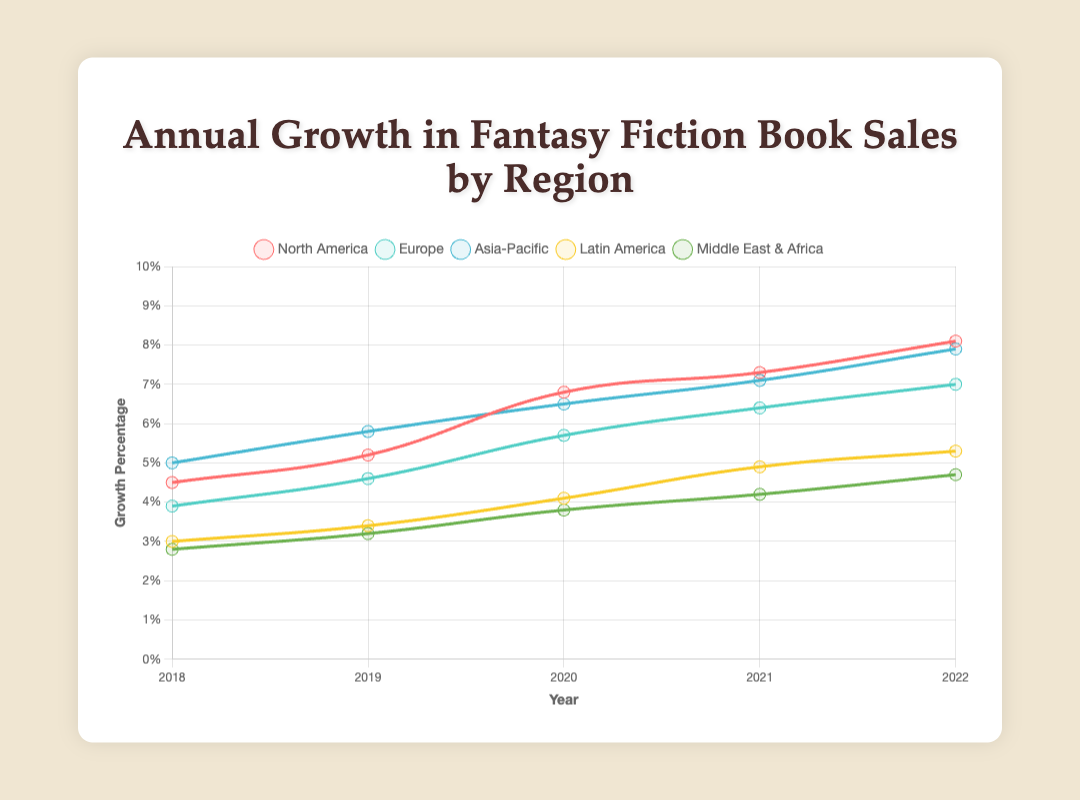Which region had the highest growth percentage in 2022? To find this, compare the final data points for each region in 2022. North America has 8.1%, Europe has 7.0%, Asia-Pacific has 7.9%, Latin America has 5.3%, and Middle East & Africa has 4.7%. North America has the highest percentage.
Answer: North America Which region had the lowest growth percentage in 2018? To determine this, compare the initial data points for each region in 2018. North America has 4.5%, Europe has 3.9%, Asia-Pacific has 5.0%, Latin America has 3.0%, and Middle East & Africa has 2.8%. Middle East & Africa has the lowest percentage.
Answer: Middle East & Africa Which region experienced the greatest increase in growth percentage from 2018 to 2022? Subtract the 2018 value from the 2022 value for each region. North America: 8.1% - 4.5% = 3.6%, Europe: 7.0% - 3.9% = 3.1%, Asia-Pacific: 7.9% - 5.0% = 2.9%, Latin America: 5.3% - 3.0% = 2.3%, Middle East & Africa: 4.7% - 2.8% = 1.9%. North America had the greatest increase.
Answer: North America Which year shows the most substantial difference between North America and Europe in terms of growth percentage? Look at the data for each year and calculate the differences. 2018: 4.5% - 3.9% = 0.6%, 2019: 5.2% - 4.6% = 0.6%, 2020: 6.8% - 5.7% = 1.1%, 2021: 7.3% - 6.4% = 0.9%, 2022: 8.1% - 7.0% = 1.1%. The years 2020 and 2022 show the most substantial difference (1.1%).
Answer: 2020 and 2022 By how much did the growth percentage in Latin America change from 2019 to 2021? Subtract the 2019 value from the 2021 value for Latin America. 4.9% - 3.4% = 1.5%.
Answer: 1.5% Which region had a consistently increasing growth percentage every year from 2018 to 2022? Check the data points for each region to ensure consistent yearly increases. North America: 4.5%, 5.2%, 6.8%, 7.3%, 8.1%; Europe: 3.9%, 4.6%, 5.7%, 6.4%, 7.0%; Asia-Pacific: 5.0%, 5.8%, 6.5%, 7.1%, 7.9%; Latin America: 3.0%, 3.4%, 4.1%, 4.9%, 5.3%; Middle East & Africa: 2.8%, 3.2%, 3.8%, 4.2%, 4.7%. All regions meet this criterion.
Answer: All regions What is the combined growth percentage of all regions in 2020? Add the 2020 values for each region. North America: 6.8%, Europe: 5.7%, Asia-Pacific: 6.5%, Latin America: 4.1%, Middle East & Africa: 3.8%. Hence, 6.8% + 5.7% + 6.5% + 4.1% + 3.8% = 26.9%.
Answer: 26.9% In which year did Asia-Pacific's growth percentage surpass Europe's by the largest margin? Calculate the annual differences between Asia-Pacific and Europe. 2018: 5.0% - 3.9% = 1.1%, 2019: 5.8% - 4.6% = 1.2%, 2020: 6.5% - 5.7% = 0.8%, 2021: 7.1% - 6.4% = 0.7%, 2022: 7.9% - 7.0% = 0.9%. The largest margin is in 2019 (1.2%).
Answer: 2019 